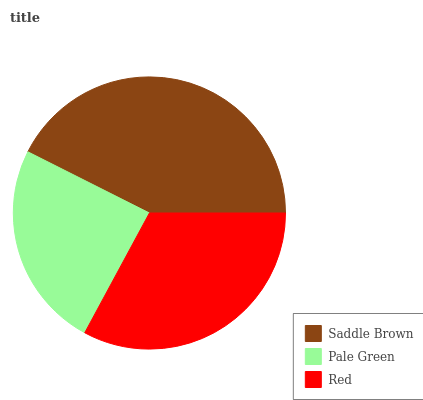Is Pale Green the minimum?
Answer yes or no. Yes. Is Saddle Brown the maximum?
Answer yes or no. Yes. Is Red the minimum?
Answer yes or no. No. Is Red the maximum?
Answer yes or no. No. Is Red greater than Pale Green?
Answer yes or no. Yes. Is Pale Green less than Red?
Answer yes or no. Yes. Is Pale Green greater than Red?
Answer yes or no. No. Is Red less than Pale Green?
Answer yes or no. No. Is Red the high median?
Answer yes or no. Yes. Is Red the low median?
Answer yes or no. Yes. Is Saddle Brown the high median?
Answer yes or no. No. Is Pale Green the low median?
Answer yes or no. No. 